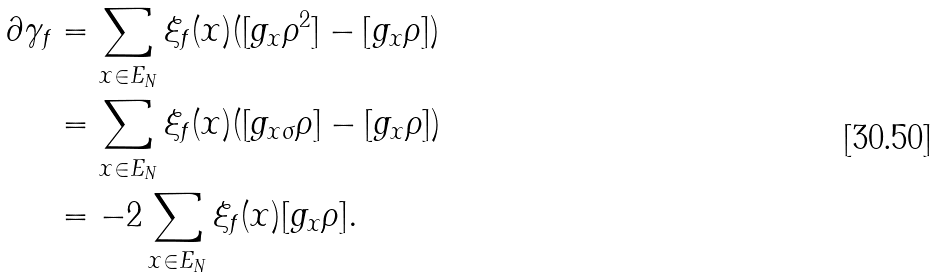<formula> <loc_0><loc_0><loc_500><loc_500>\partial \gamma _ { f } & = \sum _ { x \in E _ { N } } \xi _ { f } ( x ) ( [ g _ { x } \rho ^ { 2 } ] - [ g _ { x } \rho ] ) \\ & = \sum _ { x \in E _ { N } } \xi _ { f } ( x ) ( [ g _ { x \sigma } \rho ] - [ g _ { x } \rho ] ) \\ & = - 2 \sum _ { x \in E _ { N } } \xi _ { f } ( x ) [ g _ { x } \rho ] .</formula> 